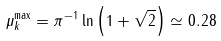<formula> <loc_0><loc_0><loc_500><loc_500>\mu _ { k } ^ { \max } = \pi ^ { - 1 } \ln \left ( 1 + \sqrt { 2 } \right ) \simeq 0 . 2 8</formula> 